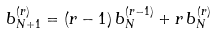<formula> <loc_0><loc_0><loc_500><loc_500>b _ { N + 1 } ^ { ( r ) } = ( r - 1 ) \, b _ { N } ^ { ( r - 1 ) } + r \, b _ { N } ^ { ( r ) }</formula> 